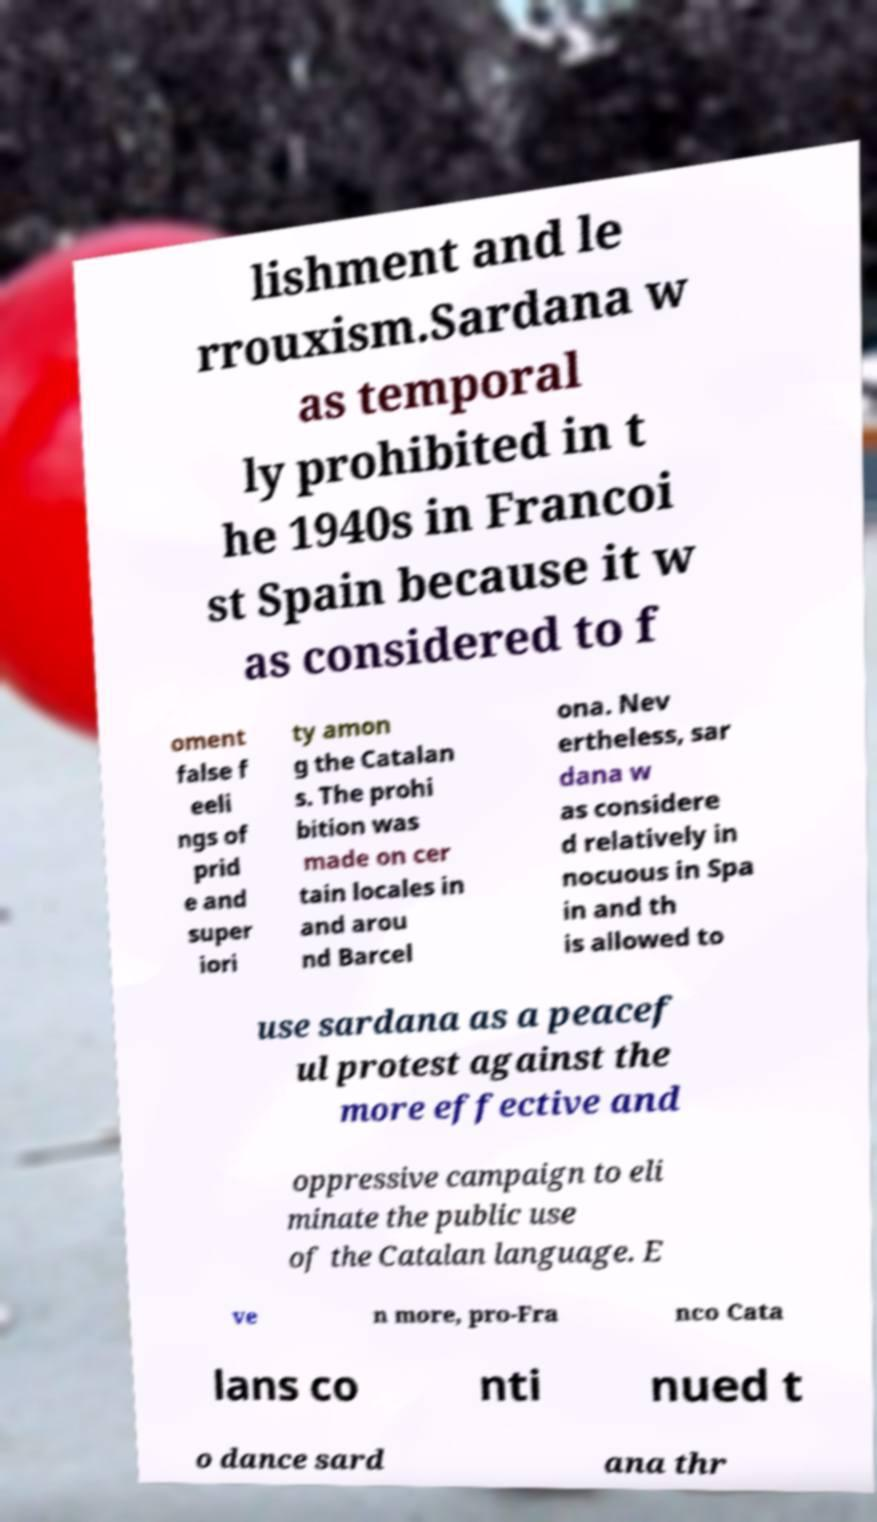Could you extract and type out the text from this image? lishment and le rrouxism.Sardana w as temporal ly prohibited in t he 1940s in Francoi st Spain because it w as considered to f oment false f eeli ngs of prid e and super iori ty amon g the Catalan s. The prohi bition was made on cer tain locales in and arou nd Barcel ona. Nev ertheless, sar dana w as considere d relatively in nocuous in Spa in and th is allowed to use sardana as a peacef ul protest against the more effective and oppressive campaign to eli minate the public use of the Catalan language. E ve n more, pro-Fra nco Cata lans co nti nued t o dance sard ana thr 